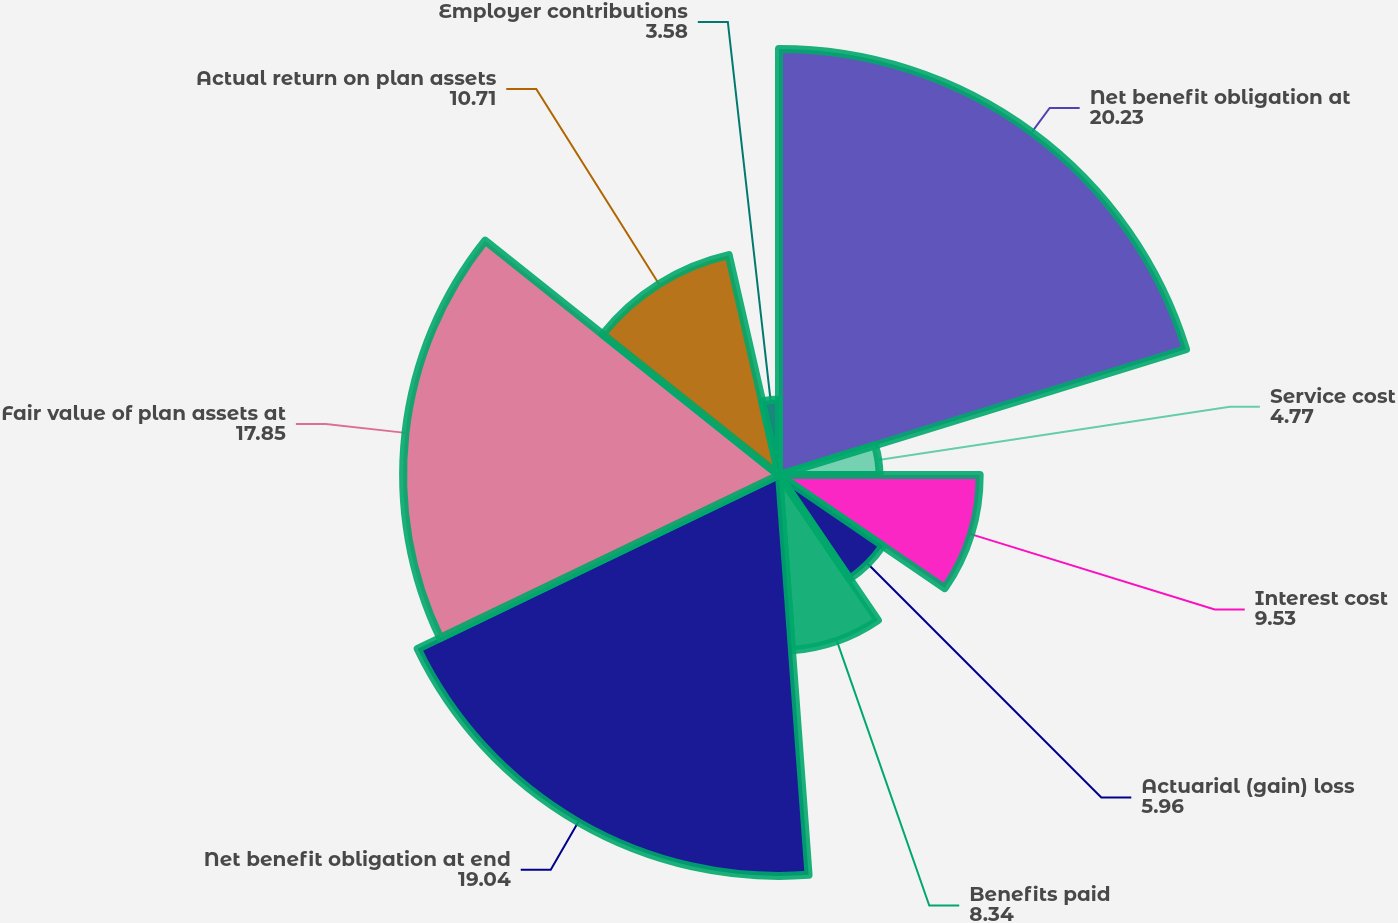Convert chart. <chart><loc_0><loc_0><loc_500><loc_500><pie_chart><fcel>Net benefit obligation at<fcel>Service cost<fcel>Interest cost<fcel>Actuarial (gain) loss<fcel>Benefits paid<fcel>Net benefit obligation at end<fcel>Fair value of plan assets at<fcel>Actual return on plan assets<fcel>Employer contributions<nl><fcel>20.23%<fcel>4.77%<fcel>9.53%<fcel>5.96%<fcel>8.34%<fcel>19.04%<fcel>17.85%<fcel>10.71%<fcel>3.58%<nl></chart> 